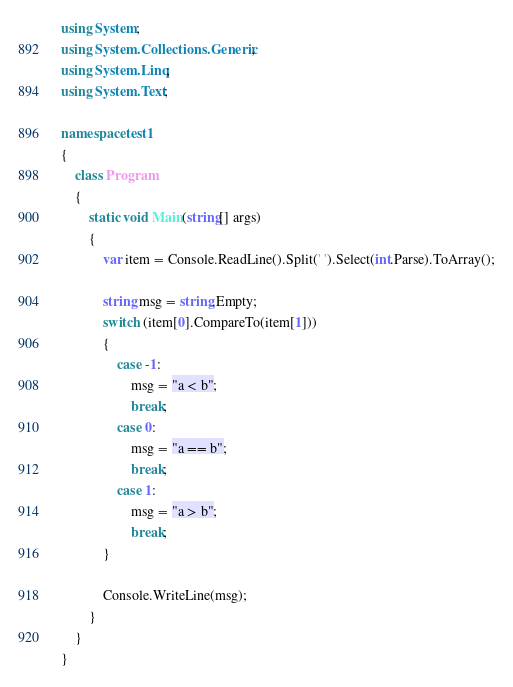Convert code to text. <code><loc_0><loc_0><loc_500><loc_500><_C#_>using System;
using System.Collections.Generic;
using System.Linq;
using System.Text;

namespace test1
{
    class Program
    {
        static void Main(string[] args)
        {
            var item = Console.ReadLine().Split(' ').Select(int.Parse).ToArray();

            string msg = string.Empty;
            switch (item[0].CompareTo(item[1]))
            {
                case -1:
                    msg = "a < b";
                    break;
                case 0:
                    msg = "a == b";
                    break;
                case 1:
                    msg = "a > b";
                    break;
            }

            Console.WriteLine(msg);
        }
    }
}</code> 